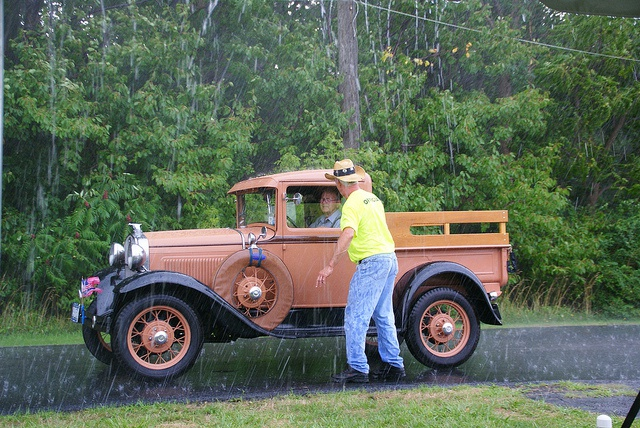Describe the objects in this image and their specific colors. I can see truck in gray, black, brown, and lightpink tones, people in gray, lightblue, beige, khaki, and black tones, and people in gray and darkgray tones in this image. 